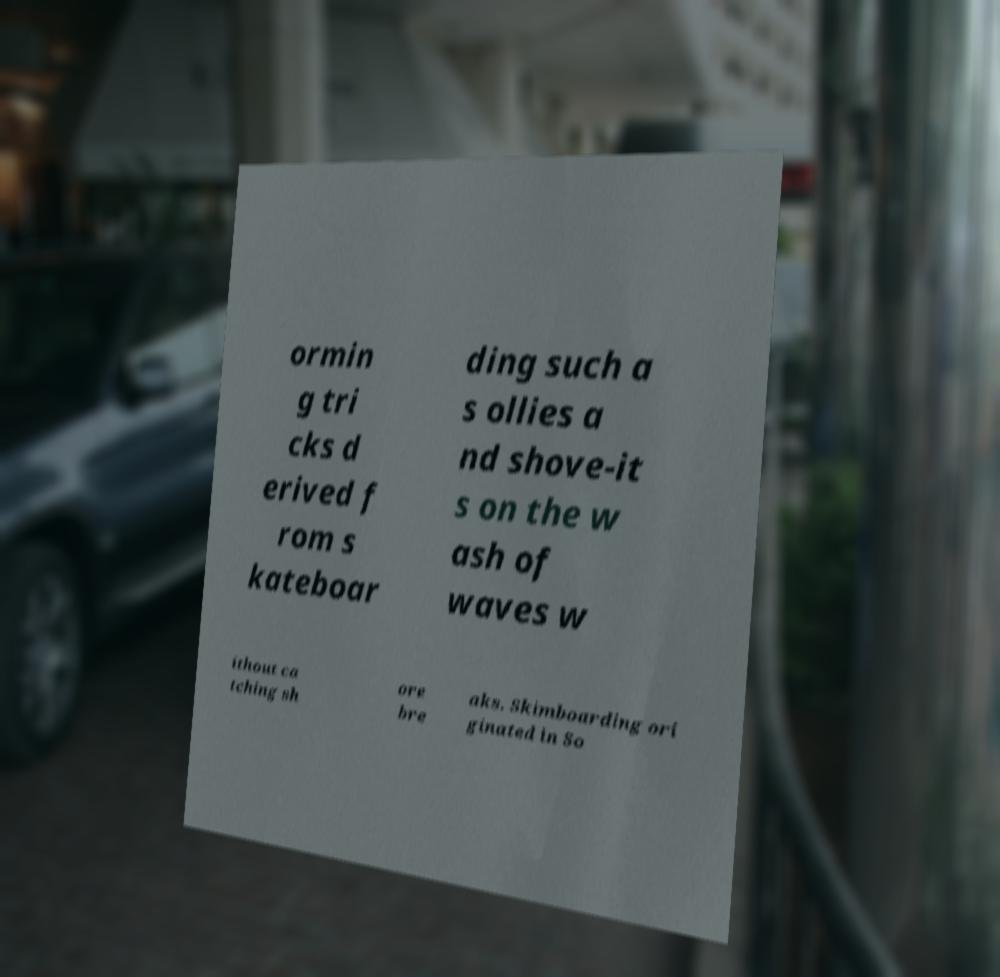For documentation purposes, I need the text within this image transcribed. Could you provide that? ormin g tri cks d erived f rom s kateboar ding such a s ollies a nd shove-it s on the w ash of waves w ithout ca tching sh ore bre aks. Skimboarding ori ginated in So 